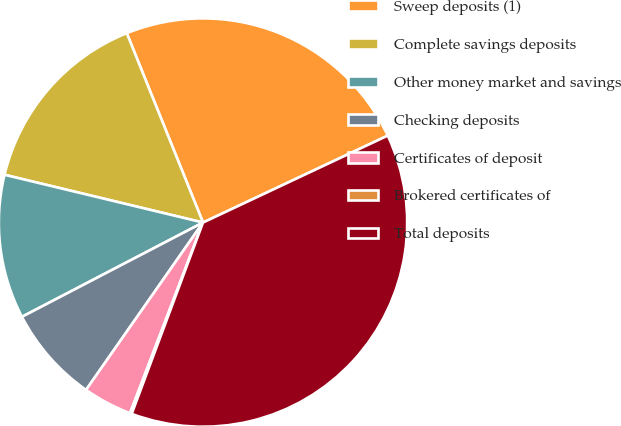<chart> <loc_0><loc_0><loc_500><loc_500><pie_chart><fcel>Sweep deposits (1)<fcel>Complete savings deposits<fcel>Other money market and savings<fcel>Checking deposits<fcel>Certificates of deposit<fcel>Brokered certificates of<fcel>Total deposits<nl><fcel>24.09%<fcel>15.15%<fcel>11.4%<fcel>7.65%<fcel>3.89%<fcel>0.14%<fcel>37.68%<nl></chart> 